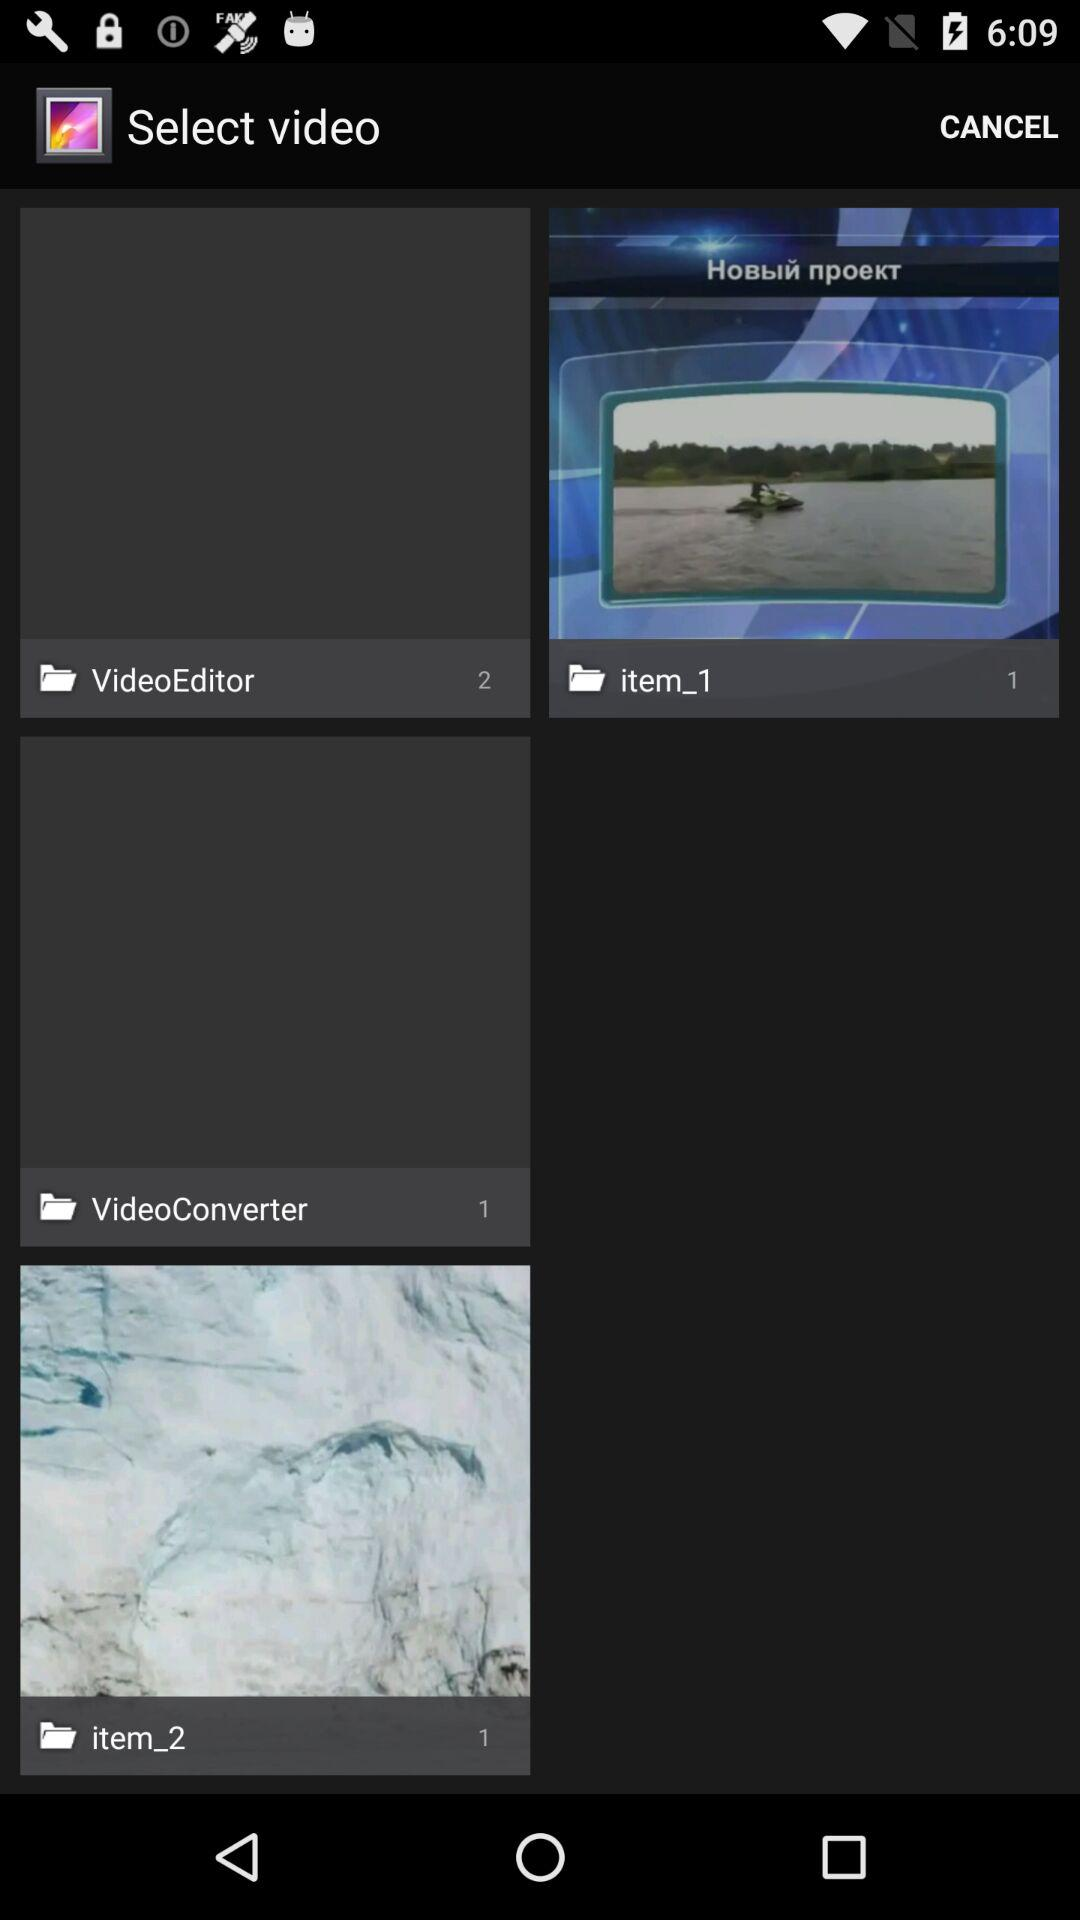How many items have the text 'item' in their title?
Answer the question using a single word or phrase. 2 